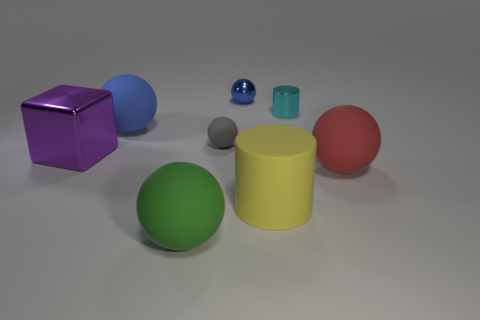Subtract all green matte balls. How many balls are left? 4 Subtract all green balls. How many balls are left? 4 Subtract 2 cylinders. How many cylinders are left? 0 Add 1 tiny green metal cylinders. How many objects exist? 9 Subtract all cylinders. How many objects are left? 6 Subtract all brown cubes. Subtract all blue spheres. How many cubes are left? 1 Subtract all blue cubes. How many blue spheres are left? 2 Subtract all big blocks. Subtract all blue shiny balls. How many objects are left? 6 Add 4 purple metallic objects. How many purple metallic objects are left? 5 Add 4 brown balls. How many brown balls exist? 4 